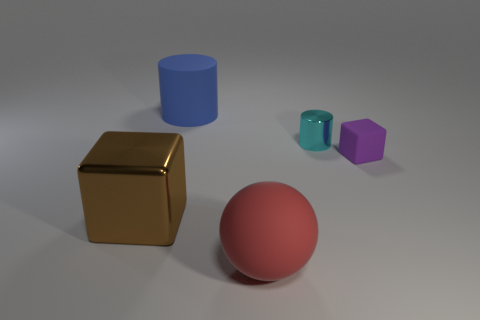What materials do the objects in the image appear to be made from? The objects in the image appear to be rendered with different material properties. The cube looks metallic with a gold sheen, the large ball seems to have a matte surface, possibly representing a clay or plastic material. The blue cylinder seems to have a slight gloss, suggestive of painted metal or plastic, while the small teal cylinder has a high gloss, resembling glass. Lastly, the purple object, with its unique pentagonal shape, could be made of a matte plastic-like material. 